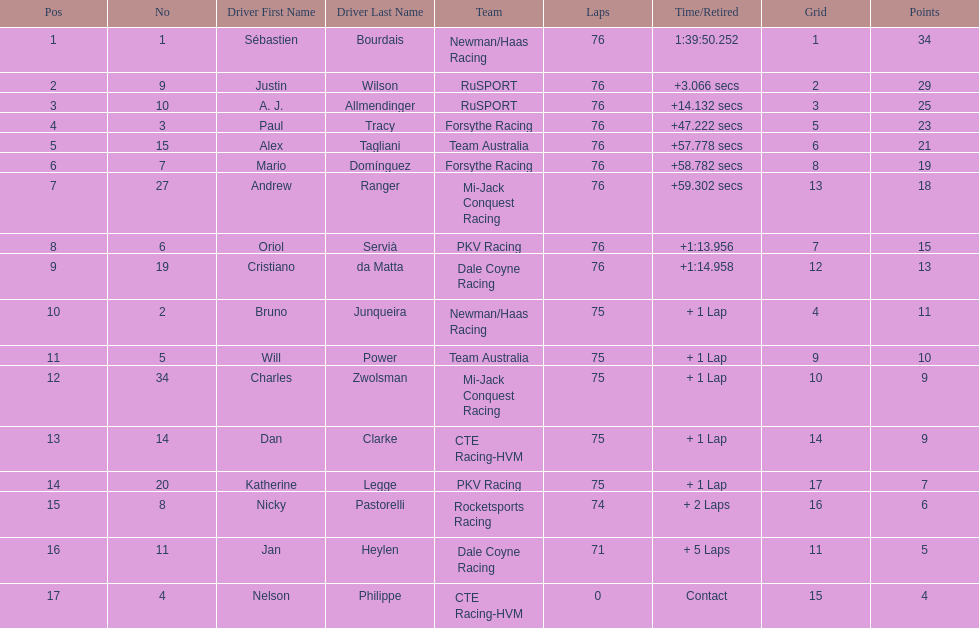How many positions are held by canada? 3. 